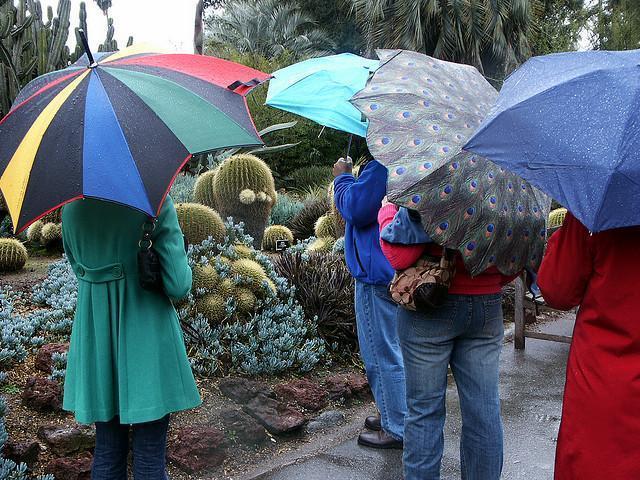How many umbrellas are in the picture?
Give a very brief answer. 4. How many people are there?
Give a very brief answer. 4. 